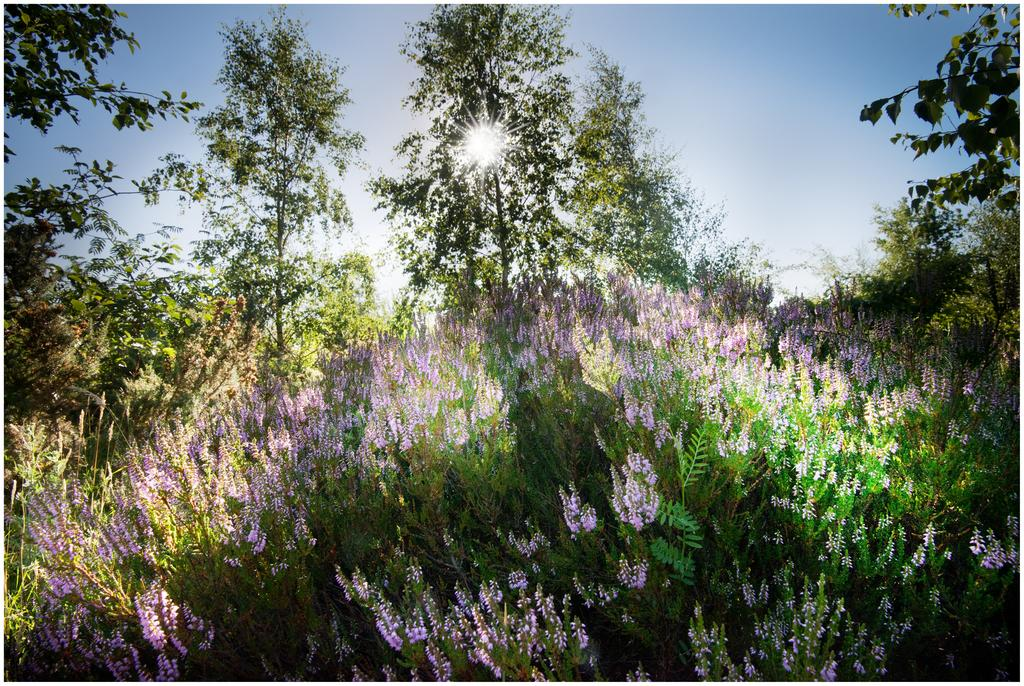What type of plants can be seen in the image? There are beautiful plants with purple flowers in the image. Are there any other plants or trees in the vicinity? Yes, there are other trees around the plants. Can you describe the lighting in the image? There is bright sunshine coming from the middle of one of the trees. What type of legal advice can be sought from the plants in the image? The plants in the image do not provide legal advice, as they are not sentient beings or professionals. 